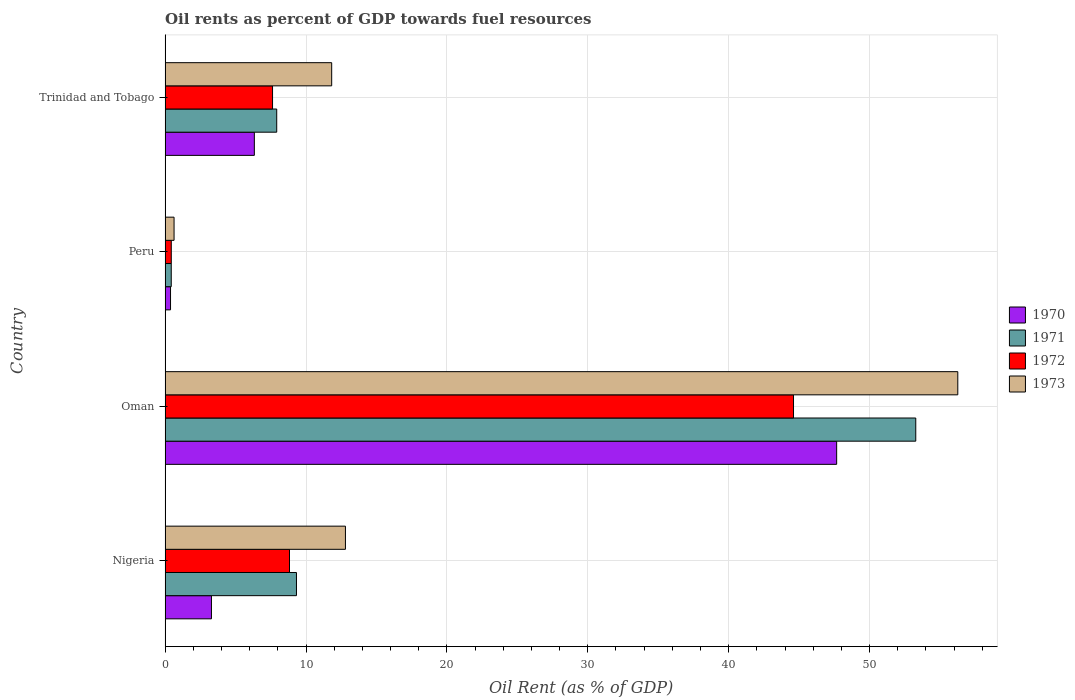Are the number of bars per tick equal to the number of legend labels?
Give a very brief answer. Yes. What is the label of the 3rd group of bars from the top?
Your response must be concise. Oman. What is the oil rent in 1973 in Peru?
Your answer should be very brief. 0.64. Across all countries, what is the maximum oil rent in 1972?
Offer a very short reply. 44.6. Across all countries, what is the minimum oil rent in 1972?
Offer a terse response. 0.44. In which country was the oil rent in 1970 maximum?
Your answer should be very brief. Oman. In which country was the oil rent in 1973 minimum?
Keep it short and to the point. Peru. What is the total oil rent in 1972 in the graph?
Keep it short and to the point. 61.49. What is the difference between the oil rent in 1972 in Oman and that in Peru?
Ensure brevity in your answer.  44.16. What is the difference between the oil rent in 1972 in Trinidad and Tobago and the oil rent in 1973 in Peru?
Your answer should be compact. 6.99. What is the average oil rent in 1971 per country?
Your answer should be compact. 17.74. What is the difference between the oil rent in 1973 and oil rent in 1972 in Oman?
Make the answer very short. 11.66. What is the ratio of the oil rent in 1971 in Peru to that in Trinidad and Tobago?
Offer a very short reply. 0.06. Is the oil rent in 1973 in Oman less than that in Trinidad and Tobago?
Your answer should be compact. No. What is the difference between the highest and the second highest oil rent in 1971?
Offer a terse response. 43.95. What is the difference between the highest and the lowest oil rent in 1970?
Ensure brevity in your answer.  47.28. In how many countries, is the oil rent in 1972 greater than the average oil rent in 1972 taken over all countries?
Offer a very short reply. 1. Is the sum of the oil rent in 1970 in Oman and Trinidad and Tobago greater than the maximum oil rent in 1973 across all countries?
Provide a short and direct response. No. What does the 4th bar from the top in Peru represents?
Provide a succinct answer. 1970. Is it the case that in every country, the sum of the oil rent in 1971 and oil rent in 1972 is greater than the oil rent in 1970?
Make the answer very short. Yes. How many bars are there?
Your answer should be very brief. 16. Are all the bars in the graph horizontal?
Your response must be concise. Yes. What is the difference between two consecutive major ticks on the X-axis?
Keep it short and to the point. 10. Are the values on the major ticks of X-axis written in scientific E-notation?
Your response must be concise. No. Where does the legend appear in the graph?
Keep it short and to the point. Center right. How many legend labels are there?
Provide a short and direct response. 4. How are the legend labels stacked?
Offer a very short reply. Vertical. What is the title of the graph?
Ensure brevity in your answer.  Oil rents as percent of GDP towards fuel resources. What is the label or title of the X-axis?
Offer a terse response. Oil Rent (as % of GDP). What is the Oil Rent (as % of GDP) in 1970 in Nigeria?
Offer a very short reply. 3.29. What is the Oil Rent (as % of GDP) of 1971 in Nigeria?
Ensure brevity in your answer.  9.32. What is the Oil Rent (as % of GDP) of 1972 in Nigeria?
Give a very brief answer. 8.83. What is the Oil Rent (as % of GDP) in 1973 in Nigeria?
Give a very brief answer. 12.8. What is the Oil Rent (as % of GDP) of 1970 in Oman?
Offer a terse response. 47.66. What is the Oil Rent (as % of GDP) in 1971 in Oman?
Your response must be concise. 53.28. What is the Oil Rent (as % of GDP) in 1972 in Oman?
Keep it short and to the point. 44.6. What is the Oil Rent (as % of GDP) in 1973 in Oman?
Offer a very short reply. 56.26. What is the Oil Rent (as % of GDP) in 1970 in Peru?
Offer a terse response. 0.39. What is the Oil Rent (as % of GDP) of 1971 in Peru?
Keep it short and to the point. 0.44. What is the Oil Rent (as % of GDP) in 1972 in Peru?
Provide a succinct answer. 0.44. What is the Oil Rent (as % of GDP) in 1973 in Peru?
Offer a very short reply. 0.64. What is the Oil Rent (as % of GDP) of 1970 in Trinidad and Tobago?
Your answer should be compact. 6.33. What is the Oil Rent (as % of GDP) of 1971 in Trinidad and Tobago?
Offer a terse response. 7.92. What is the Oil Rent (as % of GDP) of 1972 in Trinidad and Tobago?
Offer a terse response. 7.63. What is the Oil Rent (as % of GDP) in 1973 in Trinidad and Tobago?
Your response must be concise. 11.82. Across all countries, what is the maximum Oil Rent (as % of GDP) of 1970?
Make the answer very short. 47.66. Across all countries, what is the maximum Oil Rent (as % of GDP) in 1971?
Your answer should be very brief. 53.28. Across all countries, what is the maximum Oil Rent (as % of GDP) in 1972?
Provide a succinct answer. 44.6. Across all countries, what is the maximum Oil Rent (as % of GDP) of 1973?
Make the answer very short. 56.26. Across all countries, what is the minimum Oil Rent (as % of GDP) of 1970?
Make the answer very short. 0.39. Across all countries, what is the minimum Oil Rent (as % of GDP) of 1971?
Keep it short and to the point. 0.44. Across all countries, what is the minimum Oil Rent (as % of GDP) in 1972?
Provide a succinct answer. 0.44. Across all countries, what is the minimum Oil Rent (as % of GDP) of 1973?
Your response must be concise. 0.64. What is the total Oil Rent (as % of GDP) in 1970 in the graph?
Ensure brevity in your answer.  57.67. What is the total Oil Rent (as % of GDP) in 1971 in the graph?
Give a very brief answer. 70.96. What is the total Oil Rent (as % of GDP) in 1972 in the graph?
Provide a short and direct response. 61.49. What is the total Oil Rent (as % of GDP) of 1973 in the graph?
Give a very brief answer. 81.52. What is the difference between the Oil Rent (as % of GDP) in 1970 in Nigeria and that in Oman?
Provide a short and direct response. -44.37. What is the difference between the Oil Rent (as % of GDP) in 1971 in Nigeria and that in Oman?
Make the answer very short. -43.95. What is the difference between the Oil Rent (as % of GDP) in 1972 in Nigeria and that in Oman?
Offer a terse response. -35.77. What is the difference between the Oil Rent (as % of GDP) in 1973 in Nigeria and that in Oman?
Give a very brief answer. -43.46. What is the difference between the Oil Rent (as % of GDP) in 1970 in Nigeria and that in Peru?
Keep it short and to the point. 2.9. What is the difference between the Oil Rent (as % of GDP) of 1971 in Nigeria and that in Peru?
Provide a short and direct response. 8.89. What is the difference between the Oil Rent (as % of GDP) in 1972 in Nigeria and that in Peru?
Make the answer very short. 8.39. What is the difference between the Oil Rent (as % of GDP) of 1973 in Nigeria and that in Peru?
Make the answer very short. 12.16. What is the difference between the Oil Rent (as % of GDP) of 1970 in Nigeria and that in Trinidad and Tobago?
Offer a very short reply. -3.04. What is the difference between the Oil Rent (as % of GDP) of 1971 in Nigeria and that in Trinidad and Tobago?
Your answer should be compact. 1.4. What is the difference between the Oil Rent (as % of GDP) of 1972 in Nigeria and that in Trinidad and Tobago?
Your answer should be compact. 1.2. What is the difference between the Oil Rent (as % of GDP) in 1973 in Nigeria and that in Trinidad and Tobago?
Make the answer very short. 0.98. What is the difference between the Oil Rent (as % of GDP) in 1970 in Oman and that in Peru?
Provide a short and direct response. 47.28. What is the difference between the Oil Rent (as % of GDP) of 1971 in Oman and that in Peru?
Provide a short and direct response. 52.84. What is the difference between the Oil Rent (as % of GDP) in 1972 in Oman and that in Peru?
Make the answer very short. 44.16. What is the difference between the Oil Rent (as % of GDP) in 1973 in Oman and that in Peru?
Provide a succinct answer. 55.62. What is the difference between the Oil Rent (as % of GDP) in 1970 in Oman and that in Trinidad and Tobago?
Your response must be concise. 41.33. What is the difference between the Oil Rent (as % of GDP) in 1971 in Oman and that in Trinidad and Tobago?
Make the answer very short. 45.35. What is the difference between the Oil Rent (as % of GDP) in 1972 in Oman and that in Trinidad and Tobago?
Provide a short and direct response. 36.97. What is the difference between the Oil Rent (as % of GDP) in 1973 in Oman and that in Trinidad and Tobago?
Provide a succinct answer. 44.44. What is the difference between the Oil Rent (as % of GDP) of 1970 in Peru and that in Trinidad and Tobago?
Keep it short and to the point. -5.95. What is the difference between the Oil Rent (as % of GDP) in 1971 in Peru and that in Trinidad and Tobago?
Give a very brief answer. -7.49. What is the difference between the Oil Rent (as % of GDP) in 1972 in Peru and that in Trinidad and Tobago?
Your answer should be compact. -7.19. What is the difference between the Oil Rent (as % of GDP) in 1973 in Peru and that in Trinidad and Tobago?
Keep it short and to the point. -11.19. What is the difference between the Oil Rent (as % of GDP) in 1970 in Nigeria and the Oil Rent (as % of GDP) in 1971 in Oman?
Give a very brief answer. -49.99. What is the difference between the Oil Rent (as % of GDP) of 1970 in Nigeria and the Oil Rent (as % of GDP) of 1972 in Oman?
Your answer should be very brief. -41.31. What is the difference between the Oil Rent (as % of GDP) of 1970 in Nigeria and the Oil Rent (as % of GDP) of 1973 in Oman?
Your answer should be very brief. -52.97. What is the difference between the Oil Rent (as % of GDP) of 1971 in Nigeria and the Oil Rent (as % of GDP) of 1972 in Oman?
Offer a very short reply. -35.28. What is the difference between the Oil Rent (as % of GDP) of 1971 in Nigeria and the Oil Rent (as % of GDP) of 1973 in Oman?
Provide a succinct answer. -46.94. What is the difference between the Oil Rent (as % of GDP) in 1972 in Nigeria and the Oil Rent (as % of GDP) in 1973 in Oman?
Your response must be concise. -47.43. What is the difference between the Oil Rent (as % of GDP) in 1970 in Nigeria and the Oil Rent (as % of GDP) in 1971 in Peru?
Offer a terse response. 2.85. What is the difference between the Oil Rent (as % of GDP) of 1970 in Nigeria and the Oil Rent (as % of GDP) of 1972 in Peru?
Ensure brevity in your answer.  2.85. What is the difference between the Oil Rent (as % of GDP) of 1970 in Nigeria and the Oil Rent (as % of GDP) of 1973 in Peru?
Your answer should be compact. 2.65. What is the difference between the Oil Rent (as % of GDP) in 1971 in Nigeria and the Oil Rent (as % of GDP) in 1972 in Peru?
Offer a terse response. 8.88. What is the difference between the Oil Rent (as % of GDP) in 1971 in Nigeria and the Oil Rent (as % of GDP) in 1973 in Peru?
Provide a succinct answer. 8.69. What is the difference between the Oil Rent (as % of GDP) of 1972 in Nigeria and the Oil Rent (as % of GDP) of 1973 in Peru?
Offer a terse response. 8.19. What is the difference between the Oil Rent (as % of GDP) of 1970 in Nigeria and the Oil Rent (as % of GDP) of 1971 in Trinidad and Tobago?
Your response must be concise. -4.63. What is the difference between the Oil Rent (as % of GDP) in 1970 in Nigeria and the Oil Rent (as % of GDP) in 1972 in Trinidad and Tobago?
Your response must be concise. -4.34. What is the difference between the Oil Rent (as % of GDP) of 1970 in Nigeria and the Oil Rent (as % of GDP) of 1973 in Trinidad and Tobago?
Offer a very short reply. -8.53. What is the difference between the Oil Rent (as % of GDP) in 1971 in Nigeria and the Oil Rent (as % of GDP) in 1972 in Trinidad and Tobago?
Offer a very short reply. 1.7. What is the difference between the Oil Rent (as % of GDP) in 1971 in Nigeria and the Oil Rent (as % of GDP) in 1973 in Trinidad and Tobago?
Offer a terse response. -2.5. What is the difference between the Oil Rent (as % of GDP) of 1972 in Nigeria and the Oil Rent (as % of GDP) of 1973 in Trinidad and Tobago?
Keep it short and to the point. -2.99. What is the difference between the Oil Rent (as % of GDP) of 1970 in Oman and the Oil Rent (as % of GDP) of 1971 in Peru?
Offer a terse response. 47.23. What is the difference between the Oil Rent (as % of GDP) of 1970 in Oman and the Oil Rent (as % of GDP) of 1972 in Peru?
Provide a succinct answer. 47.22. What is the difference between the Oil Rent (as % of GDP) in 1970 in Oman and the Oil Rent (as % of GDP) in 1973 in Peru?
Your answer should be very brief. 47.03. What is the difference between the Oil Rent (as % of GDP) of 1971 in Oman and the Oil Rent (as % of GDP) of 1972 in Peru?
Provide a short and direct response. 52.84. What is the difference between the Oil Rent (as % of GDP) of 1971 in Oman and the Oil Rent (as % of GDP) of 1973 in Peru?
Offer a very short reply. 52.64. What is the difference between the Oil Rent (as % of GDP) of 1972 in Oman and the Oil Rent (as % of GDP) of 1973 in Peru?
Provide a succinct answer. 43.96. What is the difference between the Oil Rent (as % of GDP) of 1970 in Oman and the Oil Rent (as % of GDP) of 1971 in Trinidad and Tobago?
Your answer should be compact. 39.74. What is the difference between the Oil Rent (as % of GDP) in 1970 in Oman and the Oil Rent (as % of GDP) in 1972 in Trinidad and Tobago?
Your response must be concise. 40.04. What is the difference between the Oil Rent (as % of GDP) in 1970 in Oman and the Oil Rent (as % of GDP) in 1973 in Trinidad and Tobago?
Your response must be concise. 35.84. What is the difference between the Oil Rent (as % of GDP) in 1971 in Oman and the Oil Rent (as % of GDP) in 1972 in Trinidad and Tobago?
Offer a terse response. 45.65. What is the difference between the Oil Rent (as % of GDP) in 1971 in Oman and the Oil Rent (as % of GDP) in 1973 in Trinidad and Tobago?
Keep it short and to the point. 41.45. What is the difference between the Oil Rent (as % of GDP) of 1972 in Oman and the Oil Rent (as % of GDP) of 1973 in Trinidad and Tobago?
Ensure brevity in your answer.  32.78. What is the difference between the Oil Rent (as % of GDP) in 1970 in Peru and the Oil Rent (as % of GDP) in 1971 in Trinidad and Tobago?
Your response must be concise. -7.54. What is the difference between the Oil Rent (as % of GDP) in 1970 in Peru and the Oil Rent (as % of GDP) in 1972 in Trinidad and Tobago?
Provide a succinct answer. -7.24. What is the difference between the Oil Rent (as % of GDP) in 1970 in Peru and the Oil Rent (as % of GDP) in 1973 in Trinidad and Tobago?
Give a very brief answer. -11.44. What is the difference between the Oil Rent (as % of GDP) in 1971 in Peru and the Oil Rent (as % of GDP) in 1972 in Trinidad and Tobago?
Keep it short and to the point. -7.19. What is the difference between the Oil Rent (as % of GDP) of 1971 in Peru and the Oil Rent (as % of GDP) of 1973 in Trinidad and Tobago?
Provide a succinct answer. -11.39. What is the difference between the Oil Rent (as % of GDP) in 1972 in Peru and the Oil Rent (as % of GDP) in 1973 in Trinidad and Tobago?
Provide a succinct answer. -11.38. What is the average Oil Rent (as % of GDP) of 1970 per country?
Provide a succinct answer. 14.42. What is the average Oil Rent (as % of GDP) in 1971 per country?
Your answer should be very brief. 17.74. What is the average Oil Rent (as % of GDP) of 1972 per country?
Offer a terse response. 15.37. What is the average Oil Rent (as % of GDP) of 1973 per country?
Your response must be concise. 20.38. What is the difference between the Oil Rent (as % of GDP) of 1970 and Oil Rent (as % of GDP) of 1971 in Nigeria?
Give a very brief answer. -6.03. What is the difference between the Oil Rent (as % of GDP) in 1970 and Oil Rent (as % of GDP) in 1972 in Nigeria?
Offer a very short reply. -5.54. What is the difference between the Oil Rent (as % of GDP) in 1970 and Oil Rent (as % of GDP) in 1973 in Nigeria?
Offer a terse response. -9.51. What is the difference between the Oil Rent (as % of GDP) in 1971 and Oil Rent (as % of GDP) in 1972 in Nigeria?
Give a very brief answer. 0.49. What is the difference between the Oil Rent (as % of GDP) of 1971 and Oil Rent (as % of GDP) of 1973 in Nigeria?
Offer a very short reply. -3.48. What is the difference between the Oil Rent (as % of GDP) of 1972 and Oil Rent (as % of GDP) of 1973 in Nigeria?
Your response must be concise. -3.97. What is the difference between the Oil Rent (as % of GDP) in 1970 and Oil Rent (as % of GDP) in 1971 in Oman?
Make the answer very short. -5.61. What is the difference between the Oil Rent (as % of GDP) of 1970 and Oil Rent (as % of GDP) of 1972 in Oman?
Your response must be concise. 3.06. What is the difference between the Oil Rent (as % of GDP) in 1970 and Oil Rent (as % of GDP) in 1973 in Oman?
Keep it short and to the point. -8.6. What is the difference between the Oil Rent (as % of GDP) in 1971 and Oil Rent (as % of GDP) in 1972 in Oman?
Your answer should be compact. 8.68. What is the difference between the Oil Rent (as % of GDP) of 1971 and Oil Rent (as % of GDP) of 1973 in Oman?
Give a very brief answer. -2.98. What is the difference between the Oil Rent (as % of GDP) of 1972 and Oil Rent (as % of GDP) of 1973 in Oman?
Provide a succinct answer. -11.66. What is the difference between the Oil Rent (as % of GDP) in 1970 and Oil Rent (as % of GDP) in 1971 in Peru?
Your answer should be very brief. -0.05. What is the difference between the Oil Rent (as % of GDP) of 1970 and Oil Rent (as % of GDP) of 1972 in Peru?
Offer a very short reply. -0.05. What is the difference between the Oil Rent (as % of GDP) of 1970 and Oil Rent (as % of GDP) of 1973 in Peru?
Your response must be concise. -0.25. What is the difference between the Oil Rent (as % of GDP) in 1971 and Oil Rent (as % of GDP) in 1972 in Peru?
Your answer should be compact. -0. What is the difference between the Oil Rent (as % of GDP) of 1971 and Oil Rent (as % of GDP) of 1973 in Peru?
Offer a terse response. -0.2. What is the difference between the Oil Rent (as % of GDP) of 1972 and Oil Rent (as % of GDP) of 1973 in Peru?
Offer a terse response. -0.2. What is the difference between the Oil Rent (as % of GDP) of 1970 and Oil Rent (as % of GDP) of 1971 in Trinidad and Tobago?
Keep it short and to the point. -1.59. What is the difference between the Oil Rent (as % of GDP) in 1970 and Oil Rent (as % of GDP) in 1972 in Trinidad and Tobago?
Your response must be concise. -1.29. What is the difference between the Oil Rent (as % of GDP) of 1970 and Oil Rent (as % of GDP) of 1973 in Trinidad and Tobago?
Give a very brief answer. -5.49. What is the difference between the Oil Rent (as % of GDP) in 1971 and Oil Rent (as % of GDP) in 1972 in Trinidad and Tobago?
Your answer should be very brief. 0.3. What is the difference between the Oil Rent (as % of GDP) in 1971 and Oil Rent (as % of GDP) in 1973 in Trinidad and Tobago?
Make the answer very short. -3.9. What is the difference between the Oil Rent (as % of GDP) in 1972 and Oil Rent (as % of GDP) in 1973 in Trinidad and Tobago?
Give a very brief answer. -4.2. What is the ratio of the Oil Rent (as % of GDP) of 1970 in Nigeria to that in Oman?
Offer a very short reply. 0.07. What is the ratio of the Oil Rent (as % of GDP) in 1971 in Nigeria to that in Oman?
Provide a short and direct response. 0.17. What is the ratio of the Oil Rent (as % of GDP) of 1972 in Nigeria to that in Oman?
Ensure brevity in your answer.  0.2. What is the ratio of the Oil Rent (as % of GDP) in 1973 in Nigeria to that in Oman?
Your answer should be compact. 0.23. What is the ratio of the Oil Rent (as % of GDP) of 1970 in Nigeria to that in Peru?
Offer a terse response. 8.53. What is the ratio of the Oil Rent (as % of GDP) in 1971 in Nigeria to that in Peru?
Provide a succinct answer. 21.35. What is the ratio of the Oil Rent (as % of GDP) of 1972 in Nigeria to that in Peru?
Provide a succinct answer. 20.12. What is the ratio of the Oil Rent (as % of GDP) of 1973 in Nigeria to that in Peru?
Provide a succinct answer. 20.13. What is the ratio of the Oil Rent (as % of GDP) of 1970 in Nigeria to that in Trinidad and Tobago?
Your answer should be compact. 0.52. What is the ratio of the Oil Rent (as % of GDP) of 1971 in Nigeria to that in Trinidad and Tobago?
Provide a short and direct response. 1.18. What is the ratio of the Oil Rent (as % of GDP) of 1972 in Nigeria to that in Trinidad and Tobago?
Make the answer very short. 1.16. What is the ratio of the Oil Rent (as % of GDP) of 1973 in Nigeria to that in Trinidad and Tobago?
Your answer should be very brief. 1.08. What is the ratio of the Oil Rent (as % of GDP) in 1970 in Oman to that in Peru?
Offer a very short reply. 123.65. What is the ratio of the Oil Rent (as % of GDP) in 1971 in Oman to that in Peru?
Provide a succinct answer. 121.98. What is the ratio of the Oil Rent (as % of GDP) of 1972 in Oman to that in Peru?
Offer a very short reply. 101.64. What is the ratio of the Oil Rent (as % of GDP) in 1973 in Oman to that in Peru?
Offer a very short reply. 88.49. What is the ratio of the Oil Rent (as % of GDP) of 1970 in Oman to that in Trinidad and Tobago?
Offer a very short reply. 7.52. What is the ratio of the Oil Rent (as % of GDP) of 1971 in Oman to that in Trinidad and Tobago?
Your response must be concise. 6.73. What is the ratio of the Oil Rent (as % of GDP) of 1972 in Oman to that in Trinidad and Tobago?
Keep it short and to the point. 5.85. What is the ratio of the Oil Rent (as % of GDP) in 1973 in Oman to that in Trinidad and Tobago?
Keep it short and to the point. 4.76. What is the ratio of the Oil Rent (as % of GDP) of 1970 in Peru to that in Trinidad and Tobago?
Offer a terse response. 0.06. What is the ratio of the Oil Rent (as % of GDP) of 1971 in Peru to that in Trinidad and Tobago?
Offer a very short reply. 0.06. What is the ratio of the Oil Rent (as % of GDP) of 1972 in Peru to that in Trinidad and Tobago?
Make the answer very short. 0.06. What is the ratio of the Oil Rent (as % of GDP) in 1973 in Peru to that in Trinidad and Tobago?
Ensure brevity in your answer.  0.05. What is the difference between the highest and the second highest Oil Rent (as % of GDP) of 1970?
Offer a very short reply. 41.33. What is the difference between the highest and the second highest Oil Rent (as % of GDP) in 1971?
Make the answer very short. 43.95. What is the difference between the highest and the second highest Oil Rent (as % of GDP) of 1972?
Make the answer very short. 35.77. What is the difference between the highest and the second highest Oil Rent (as % of GDP) in 1973?
Ensure brevity in your answer.  43.46. What is the difference between the highest and the lowest Oil Rent (as % of GDP) in 1970?
Keep it short and to the point. 47.28. What is the difference between the highest and the lowest Oil Rent (as % of GDP) of 1971?
Keep it short and to the point. 52.84. What is the difference between the highest and the lowest Oil Rent (as % of GDP) in 1972?
Make the answer very short. 44.16. What is the difference between the highest and the lowest Oil Rent (as % of GDP) in 1973?
Ensure brevity in your answer.  55.62. 